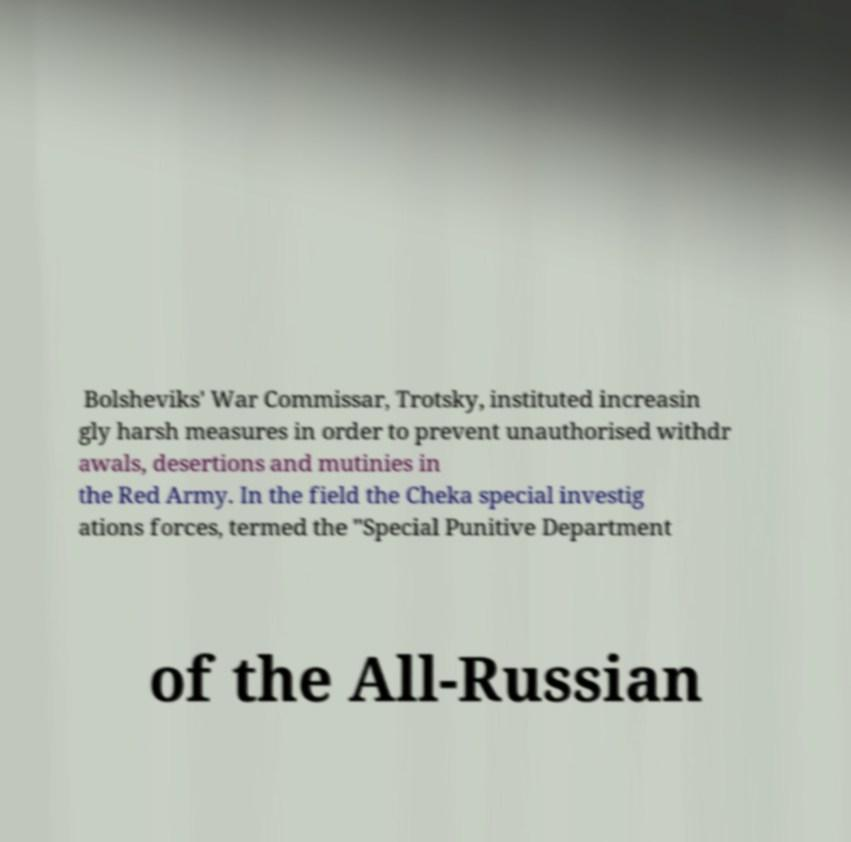What messages or text are displayed in this image? I need them in a readable, typed format. Bolsheviks' War Commissar, Trotsky, instituted increasin gly harsh measures in order to prevent unauthorised withdr awals, desertions and mutinies in the Red Army. In the field the Cheka special investig ations forces, termed the "Special Punitive Department of the All-Russian 